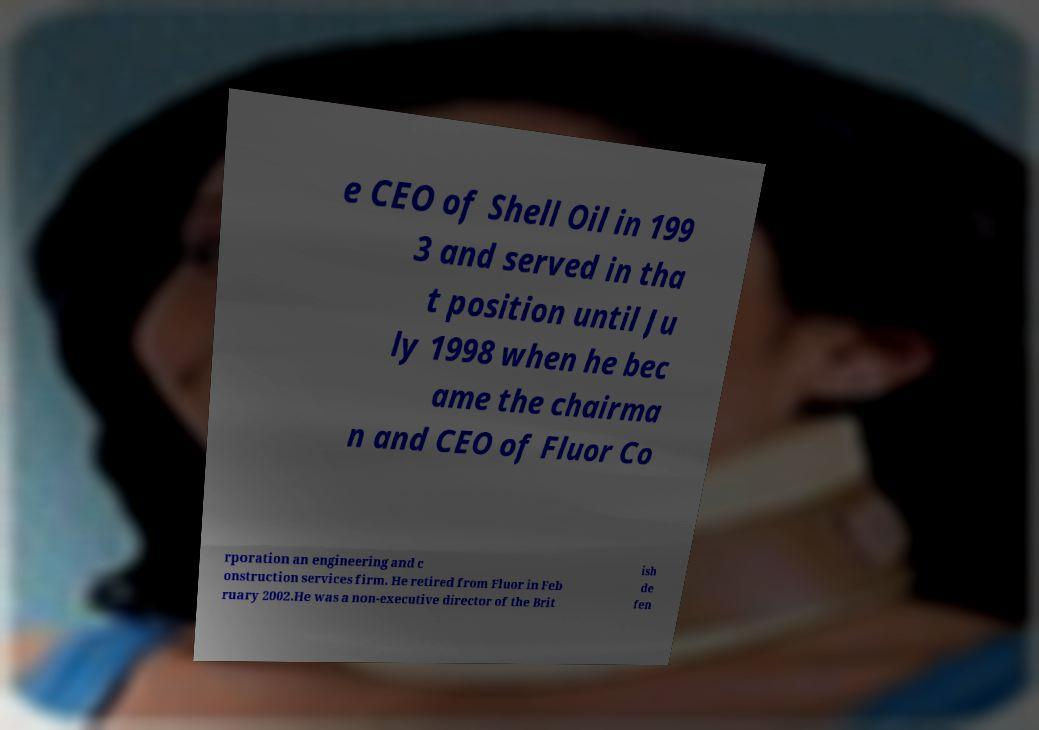Can you accurately transcribe the text from the provided image for me? e CEO of Shell Oil in 199 3 and served in tha t position until Ju ly 1998 when he bec ame the chairma n and CEO of Fluor Co rporation an engineering and c onstruction services firm. He retired from Fluor in Feb ruary 2002.He was a non-executive director of the Brit ish de fen 